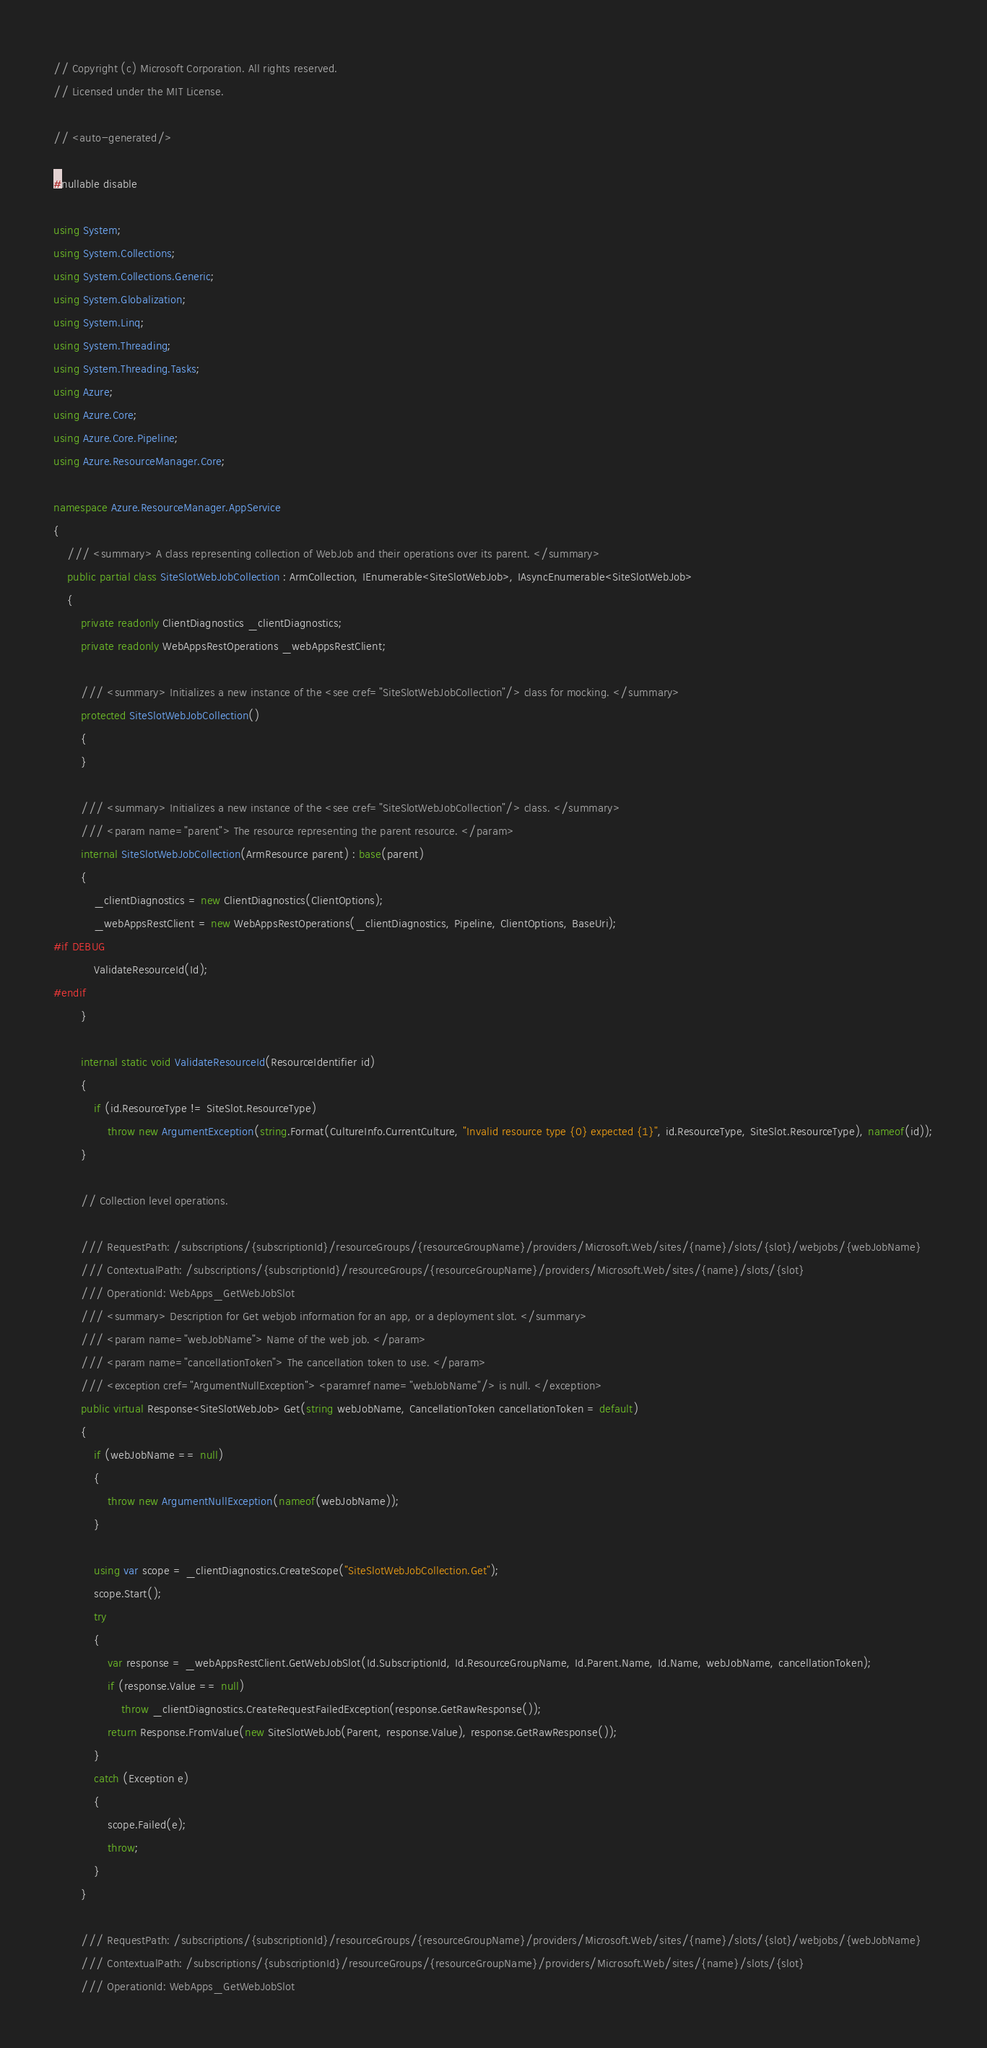<code> <loc_0><loc_0><loc_500><loc_500><_C#_>// Copyright (c) Microsoft Corporation. All rights reserved.
// Licensed under the MIT License.

// <auto-generated/>

#nullable disable

using System;
using System.Collections;
using System.Collections.Generic;
using System.Globalization;
using System.Linq;
using System.Threading;
using System.Threading.Tasks;
using Azure;
using Azure.Core;
using Azure.Core.Pipeline;
using Azure.ResourceManager.Core;

namespace Azure.ResourceManager.AppService
{
    /// <summary> A class representing collection of WebJob and their operations over its parent. </summary>
    public partial class SiteSlotWebJobCollection : ArmCollection, IEnumerable<SiteSlotWebJob>, IAsyncEnumerable<SiteSlotWebJob>
    {
        private readonly ClientDiagnostics _clientDiagnostics;
        private readonly WebAppsRestOperations _webAppsRestClient;

        /// <summary> Initializes a new instance of the <see cref="SiteSlotWebJobCollection"/> class for mocking. </summary>
        protected SiteSlotWebJobCollection()
        {
        }

        /// <summary> Initializes a new instance of the <see cref="SiteSlotWebJobCollection"/> class. </summary>
        /// <param name="parent"> The resource representing the parent resource. </param>
        internal SiteSlotWebJobCollection(ArmResource parent) : base(parent)
        {
            _clientDiagnostics = new ClientDiagnostics(ClientOptions);
            _webAppsRestClient = new WebAppsRestOperations(_clientDiagnostics, Pipeline, ClientOptions, BaseUri);
#if DEBUG
			ValidateResourceId(Id);
#endif
        }

        internal static void ValidateResourceId(ResourceIdentifier id)
        {
            if (id.ResourceType != SiteSlot.ResourceType)
                throw new ArgumentException(string.Format(CultureInfo.CurrentCulture, "Invalid resource type {0} expected {1}", id.ResourceType, SiteSlot.ResourceType), nameof(id));
        }

        // Collection level operations.

        /// RequestPath: /subscriptions/{subscriptionId}/resourceGroups/{resourceGroupName}/providers/Microsoft.Web/sites/{name}/slots/{slot}/webjobs/{webJobName}
        /// ContextualPath: /subscriptions/{subscriptionId}/resourceGroups/{resourceGroupName}/providers/Microsoft.Web/sites/{name}/slots/{slot}
        /// OperationId: WebApps_GetWebJobSlot
        /// <summary> Description for Get webjob information for an app, or a deployment slot. </summary>
        /// <param name="webJobName"> Name of the web job. </param>
        /// <param name="cancellationToken"> The cancellation token to use. </param>
        /// <exception cref="ArgumentNullException"> <paramref name="webJobName"/> is null. </exception>
        public virtual Response<SiteSlotWebJob> Get(string webJobName, CancellationToken cancellationToken = default)
        {
            if (webJobName == null)
            {
                throw new ArgumentNullException(nameof(webJobName));
            }

            using var scope = _clientDiagnostics.CreateScope("SiteSlotWebJobCollection.Get");
            scope.Start();
            try
            {
                var response = _webAppsRestClient.GetWebJobSlot(Id.SubscriptionId, Id.ResourceGroupName, Id.Parent.Name, Id.Name, webJobName, cancellationToken);
                if (response.Value == null)
                    throw _clientDiagnostics.CreateRequestFailedException(response.GetRawResponse());
                return Response.FromValue(new SiteSlotWebJob(Parent, response.Value), response.GetRawResponse());
            }
            catch (Exception e)
            {
                scope.Failed(e);
                throw;
            }
        }

        /// RequestPath: /subscriptions/{subscriptionId}/resourceGroups/{resourceGroupName}/providers/Microsoft.Web/sites/{name}/slots/{slot}/webjobs/{webJobName}
        /// ContextualPath: /subscriptions/{subscriptionId}/resourceGroups/{resourceGroupName}/providers/Microsoft.Web/sites/{name}/slots/{slot}
        /// OperationId: WebApps_GetWebJobSlot</code> 